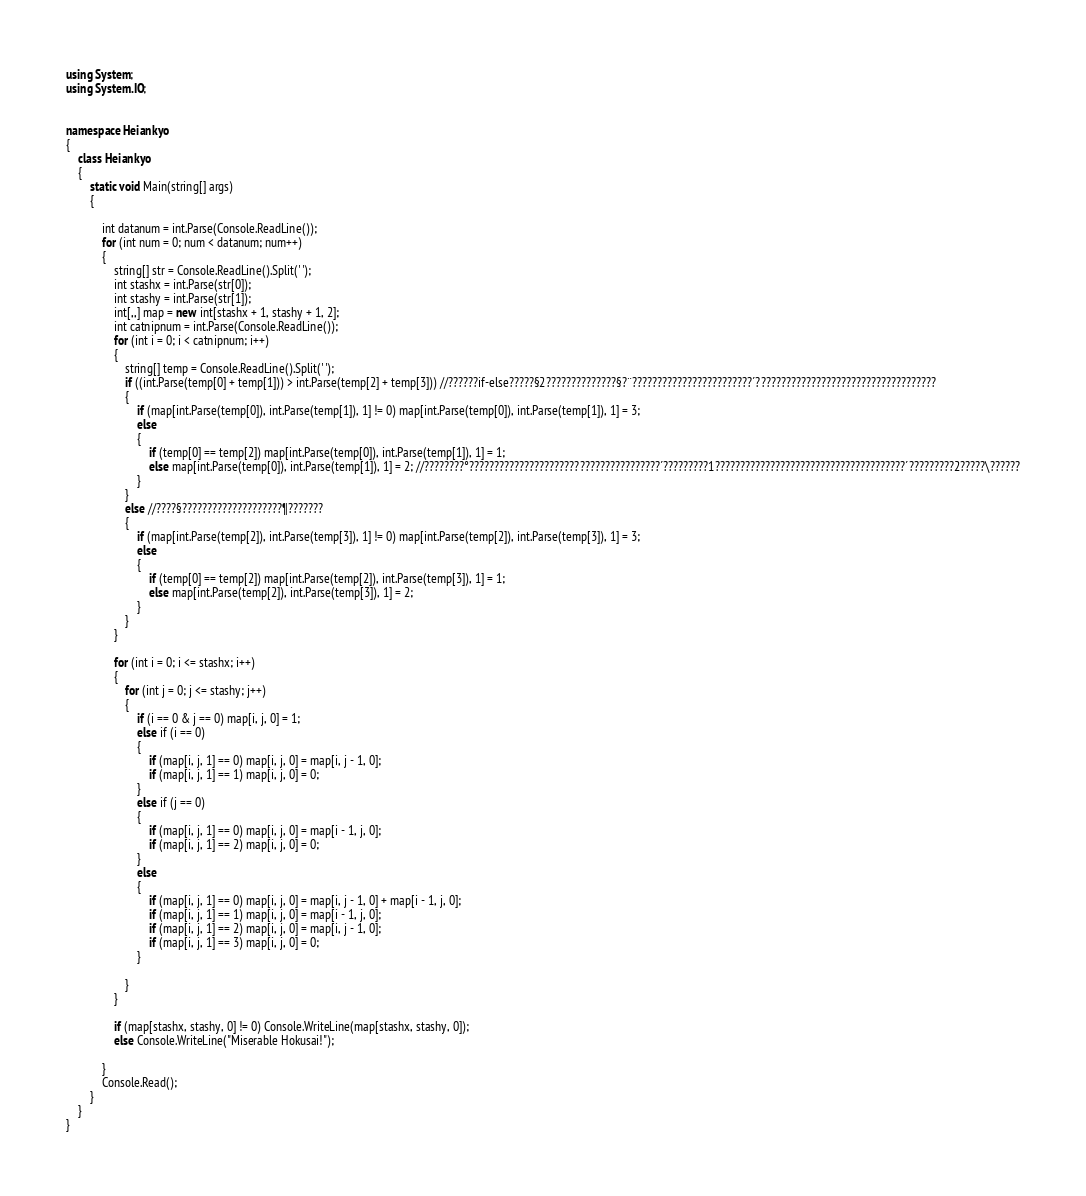Convert code to text. <code><loc_0><loc_0><loc_500><loc_500><_C#_>
using System;
using System.IO;


namespace Heiankyo
{
    class Heiankyo
    {
        static void Main(string[] args)
        {

            int datanum = int.Parse(Console.ReadLine());
            for (int num = 0; num < datanum; num++)
            {
                string[] str = Console.ReadLine().Split(' ');
                int stashx = int.Parse(str[0]);
                int stashy = int.Parse(str[1]);
                int[,,] map = new int[stashx + 1, stashy + 1, 2]; 
                int catnipnum = int.Parse(Console.ReadLine());
                for (int i = 0; i < catnipnum; i++)
                {
                    string[] temp = Console.ReadLine().Split(' ');
                    if ((int.Parse(temp[0] + temp[1])) > int.Parse(temp[2] + temp[3])) //??????if-else?????§2??????????????§?¨????????????????????????´????????????????????????????????????
                    {
                        if (map[int.Parse(temp[0]), int.Parse(temp[1]), 1] != 0) map[int.Parse(temp[0]), int.Parse(temp[1]), 1] = 3;
                        else
                        {
                            if (temp[0] == temp[2]) map[int.Parse(temp[0]), int.Parse(temp[1]), 1] = 1;
                            else map[int.Parse(temp[0]), int.Parse(temp[1]), 1] = 2; //????????°??????????????????????????????????????´?????????1??????????????????????????????????????´?????????2?????\??????
                        }
                    }
                    else //????§????????????????????¶???????
                    {
                        if (map[int.Parse(temp[2]), int.Parse(temp[3]), 1] != 0) map[int.Parse(temp[2]), int.Parse(temp[3]), 1] = 3;
                        else
                        {
                            if (temp[0] == temp[2]) map[int.Parse(temp[2]), int.Parse(temp[3]), 1] = 1;
                            else map[int.Parse(temp[2]), int.Parse(temp[3]), 1] = 2;
                        }
                    }
                }

                for (int i = 0; i <= stashx; i++)
                {
                    for (int j = 0; j <= stashy; j++)
                    {
                        if (i == 0 & j == 0) map[i, j, 0] = 1;
                        else if (i == 0)
                        {
                            if (map[i, j, 1] == 0) map[i, j, 0] = map[i, j - 1, 0];
                            if (map[i, j, 1] == 1) map[i, j, 0] = 0;
                        }
                        else if (j == 0)
                        {
                            if (map[i, j, 1] == 0) map[i, j, 0] = map[i - 1, j, 0];
                            if (map[i, j, 1] == 2) map[i, j, 0] = 0;
                        }
                        else
                        {
                            if (map[i, j, 1] == 0) map[i, j, 0] = map[i, j - 1, 0] + map[i - 1, j, 0];
                            if (map[i, j, 1] == 1) map[i, j, 0] = map[i - 1, j, 0];
                            if (map[i, j, 1] == 2) map[i, j, 0] = map[i, j - 1, 0];
                            if (map[i, j, 1] == 3) map[i, j, 0] = 0;
                        }

                    }
                }

                if (map[stashx, stashy, 0] != 0) Console.WriteLine(map[stashx, stashy, 0]);
                else Console.WriteLine("Miserable Hokusai!");

            }
            Console.Read();
        }
    }
}</code> 